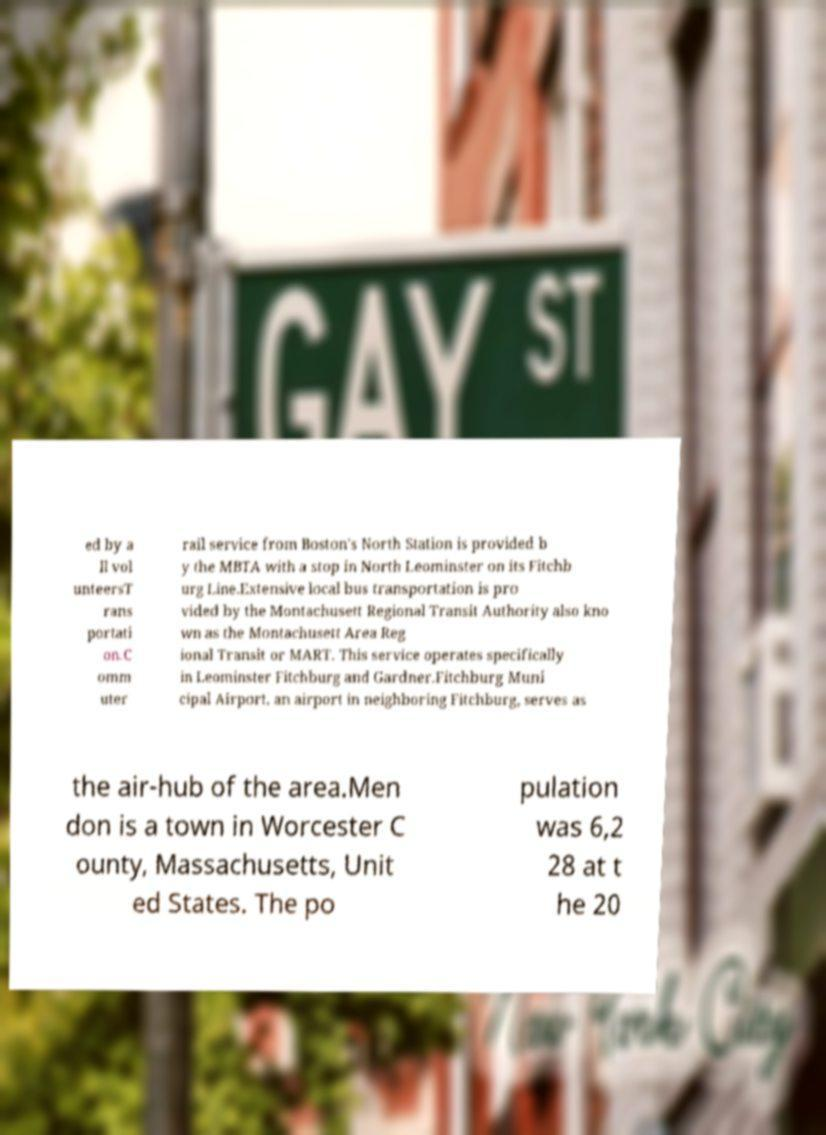Please identify and transcribe the text found in this image. ed by a ll vol unteersT rans portati on.C omm uter rail service from Boston's North Station is provided b y the MBTA with a stop in North Leominster on its Fitchb urg Line.Extensive local bus transportation is pro vided by the Montachusett Regional Transit Authority also kno wn as the Montachusett Area Reg ional Transit or MART. This service operates specifically in Leominster Fitchburg and Gardner.Fitchburg Muni cipal Airport, an airport in neighboring Fitchburg, serves as the air-hub of the area.Men don is a town in Worcester C ounty, Massachusetts, Unit ed States. The po pulation was 6,2 28 at t he 20 